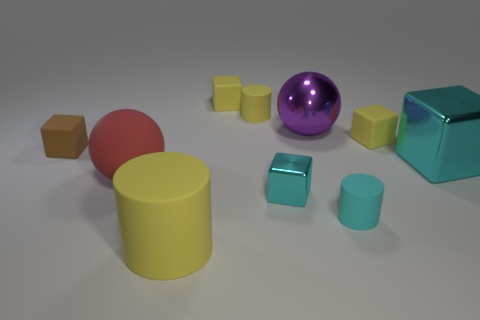Could you estimate the number of yellow objects present? Sure, within the image there are a total of four yellow objects. The objects consist of one large cylinder, two smaller cubes, and a smaller cylindrical piece. 